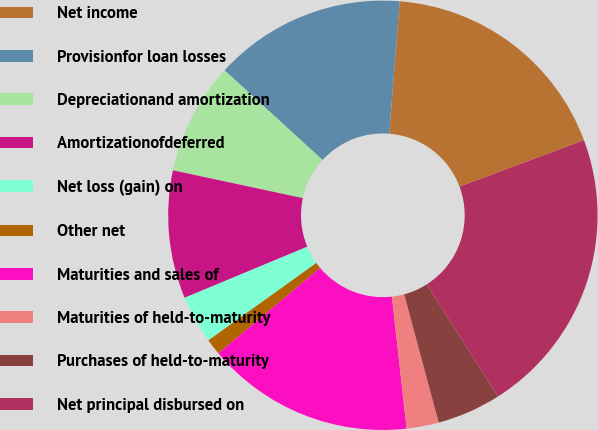Convert chart to OTSL. <chart><loc_0><loc_0><loc_500><loc_500><pie_chart><fcel>Net income<fcel>Provisionfor loan losses<fcel>Depreciationand amortization<fcel>Amortizationofdeferred<fcel>Net loss (gain) on<fcel>Other net<fcel>Maturities and sales of<fcel>Maturities of held-to-maturity<fcel>Purchases of held-to-maturity<fcel>Net principal disbursed on<nl><fcel>18.07%<fcel>14.45%<fcel>8.44%<fcel>9.64%<fcel>3.62%<fcel>1.21%<fcel>15.66%<fcel>2.42%<fcel>4.82%<fcel>21.68%<nl></chart> 